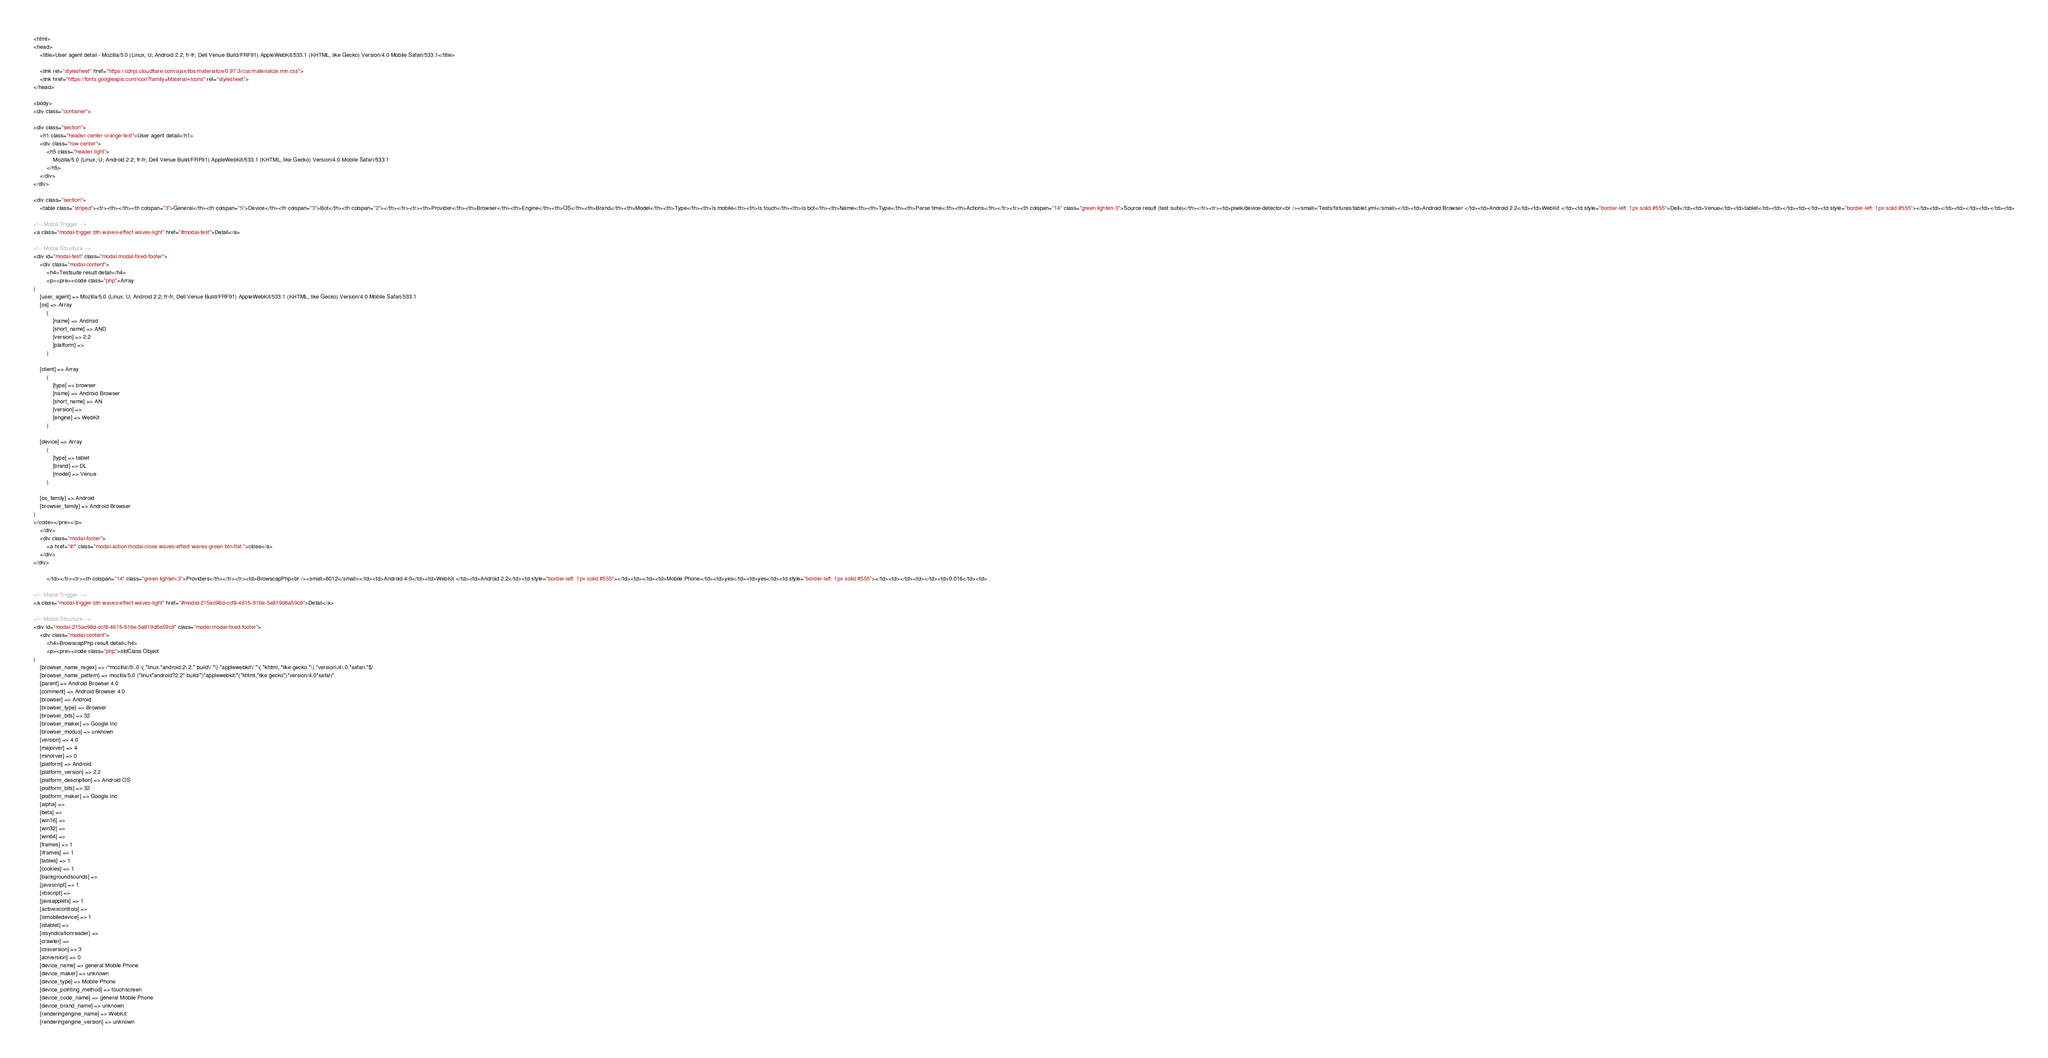<code> <loc_0><loc_0><loc_500><loc_500><_HTML_>
<html>
<head>
    <title>User agent detail - Mozilla/5.0 (Linux; U; Android 2.2; fr-fr; Dell Venue Build/FRF91) AppleWebKit/533.1 (KHTML, like Gecko) Version/4.0 Mobile Safari/533.1</title>
        
    <link rel="stylesheet" href="https://cdnjs.cloudflare.com/ajax/libs/materialize/0.97.3/css/materialize.min.css">
    <link href="https://fonts.googleapis.com/icon?family=Material+Icons" rel="stylesheet">
</head>
        
<body>
<div class="container">
    
<div class="section">
	<h1 class="header center orange-text">User agent detail</h1>
	<div class="row center">
        <h5 class="header light">
            Mozilla/5.0 (Linux; U; Android 2.2; fr-fr; Dell Venue Build/FRF91) AppleWebKit/533.1 (KHTML, like Gecko) Version/4.0 Mobile Safari/533.1
        </h5>
	</div>
</div>   

<div class="section">
    <table class="striped"><tr><th></th><th colspan="3">General</th><th colspan="5">Device</th><th colspan="3">Bot</th><th colspan="2"></th></tr><tr><th>Provider</th><th>Browser</th><th>Engine</th><th>OS</th><th>Brand</th><th>Model</th><th>Type</th><th>Is mobile</th><th>Is touch</th><th>Is bot</th><th>Name</th><th>Type</th><th>Parse time</th><th>Actions</th></tr><tr><th colspan="14" class="green lighten-3">Source result (test suite)</th></tr><tr><td>piwik/device-detector<br /><small>/Tests/fixtures/tablet.yml</small></td><td>Android Browser </td><td>Android 2.2</td><td>WebKit </td><td style="border-left: 1px solid #555">Dell</td><td>Venue</td><td>tablet</td><td></td><td></td><td style="border-left: 1px solid #555"></td><td></td><td></td><td></td><td>
                
<!-- Modal Trigger -->
<a class="modal-trigger btn waves-effect waves-light" href="#modal-test">Detail</a>

<!-- Modal Structure -->
<div id="modal-test" class="modal modal-fixed-footer">
    <div class="modal-content">
        <h4>Testsuite result detail</h4>
        <p><pre><code class="php">Array
(
    [user_agent] => Mozilla/5.0 (Linux; U; Android 2.2; fr-fr; Dell Venue Build/FRF91) AppleWebKit/533.1 (KHTML, like Gecko) Version/4.0 Mobile Safari/533.1
    [os] => Array
        (
            [name] => Android
            [short_name] => AND
            [version] => 2.2
            [platform] => 
        )

    [client] => Array
        (
            [type] => browser
            [name] => Android Browser
            [short_name] => AN
            [version] => 
            [engine] => WebKit
        )

    [device] => Array
        (
            [type] => tablet
            [brand] => DL
            [model] => Venue
        )

    [os_family] => Android
    [browser_family] => Android Browser
)
</code></pre></p>
    </div>
    <div class="modal-footer">
        <a href="#!" class="modal-action modal-close waves-effect waves-green btn-flat ">close</a>
    </div>
</div>
                
        </td></tr><tr><th colspan="14" class="green lighten-3">Providers</th></tr><tr><td>BrowscapPhp<br /><small>6012</small></td><td>Android 4.0</td><td>WebKit </td><td>Android 2.2</td><td style="border-left: 1px solid #555"></td><td></td><td>Mobile Phone</td><td>yes</td><td>yes</td><td style="border-left: 1px solid #555"></td><td></td><td></td><td>0.016</td><td>
                
<!-- Modal Trigger -->
<a class="modal-trigger btn waves-effect waves-light" href="#modal-215ac98d-ccf8-4615-916e-5a819d6a59c9">Detail</a>

<!-- Modal Structure -->
<div id="modal-215ac98d-ccf8-4615-916e-5a819d6a59c9" class="modal modal-fixed-footer">
    <div class="modal-content">
        <h4>BrowscapPhp result detail</h4>
        <p><pre><code class="php">stdClass Object
(
    [browser_name_regex] => /^mozilla\/5\.0 \(.*linux.*android.2\.2.* build\/.*\).*applewebkit\/.*\(.*khtml,.*like gecko.*\).*version\/4\.0.*safari.*$/
    [browser_name_pattern] => mozilla/5.0 (*linux*android?2.2* build/*)*applewebkit/*(*khtml,*like gecko*)*version/4.0*safari*
    [parent] => Android Browser 4.0
    [comment] => Android Browser 4.0
    [browser] => Android
    [browser_type] => Browser
    [browser_bits] => 32
    [browser_maker] => Google Inc
    [browser_modus] => unknown
    [version] => 4.0
    [majorver] => 4
    [minorver] => 0
    [platform] => Android
    [platform_version] => 2.2
    [platform_description] => Android OS
    [platform_bits] => 32
    [platform_maker] => Google Inc
    [alpha] => 
    [beta] => 
    [win16] => 
    [win32] => 
    [win64] => 
    [frames] => 1
    [iframes] => 1
    [tables] => 1
    [cookies] => 1
    [backgroundsounds] => 
    [javascript] => 1
    [vbscript] => 
    [javaapplets] => 1
    [activexcontrols] => 
    [ismobiledevice] => 1
    [istablet] => 
    [issyndicationreader] => 
    [crawler] => 
    [cssversion] => 3
    [aolversion] => 0
    [device_name] => general Mobile Phone
    [device_maker] => unknown
    [device_type] => Mobile Phone
    [device_pointing_method] => touchscreen
    [device_code_name] => general Mobile Phone
    [device_brand_name] => unknown
    [renderingengine_name] => WebKit
    [renderingengine_version] => unknown</code> 